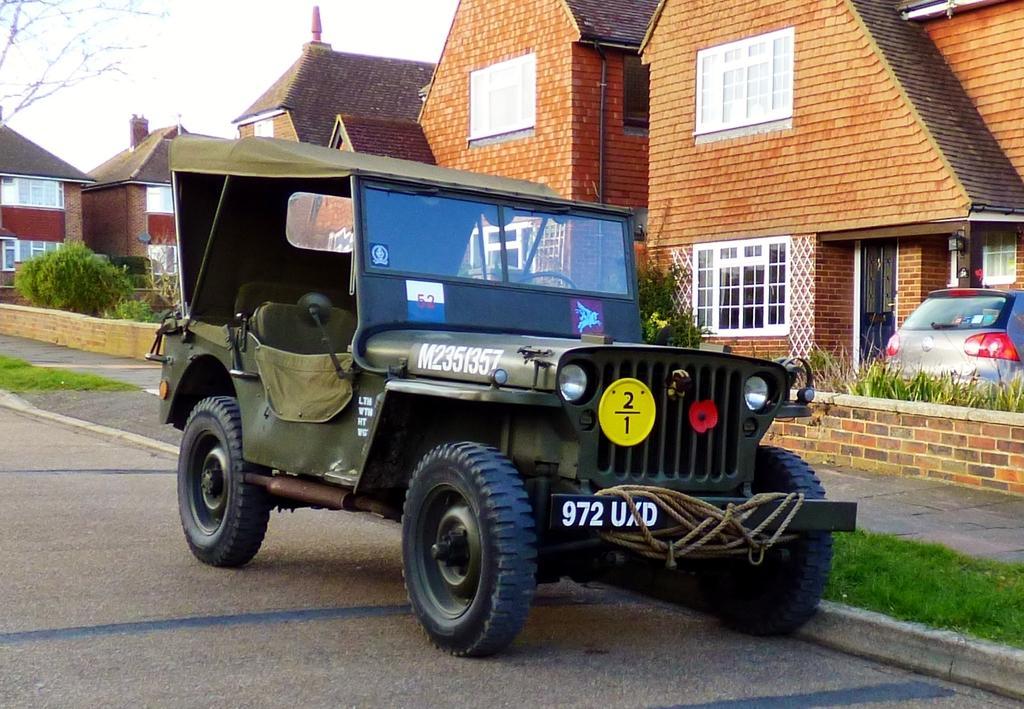In one or two sentences, can you explain what this image depicts? In this image we can see the vehicle parked on the path. We can also see the roof houses, car, plants and also the grass and a tree on the left. Sky is also visible in this image. 